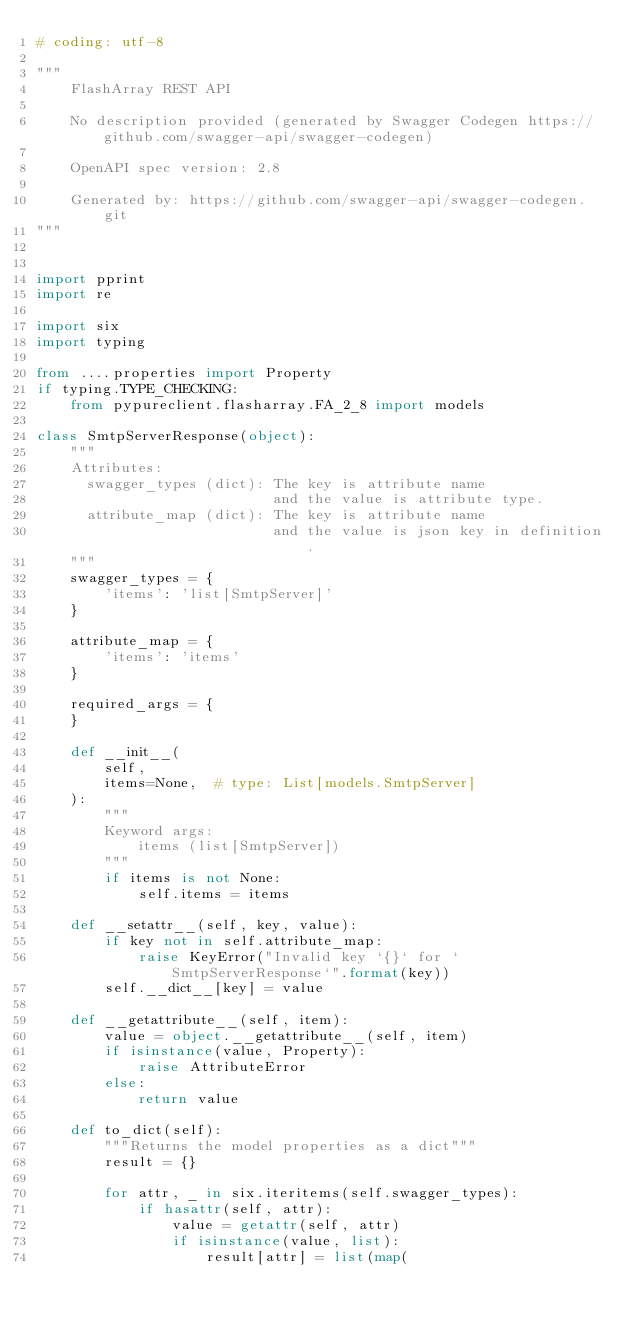Convert code to text. <code><loc_0><loc_0><loc_500><loc_500><_Python_># coding: utf-8

"""
    FlashArray REST API

    No description provided (generated by Swagger Codegen https://github.com/swagger-api/swagger-codegen)

    OpenAPI spec version: 2.8
    
    Generated by: https://github.com/swagger-api/swagger-codegen.git
"""


import pprint
import re

import six
import typing

from ....properties import Property
if typing.TYPE_CHECKING:
    from pypureclient.flasharray.FA_2_8 import models

class SmtpServerResponse(object):
    """
    Attributes:
      swagger_types (dict): The key is attribute name
                            and the value is attribute type.
      attribute_map (dict): The key is attribute name
                            and the value is json key in definition.
    """
    swagger_types = {
        'items': 'list[SmtpServer]'
    }

    attribute_map = {
        'items': 'items'
    }

    required_args = {
    }

    def __init__(
        self,
        items=None,  # type: List[models.SmtpServer]
    ):
        """
        Keyword args:
            items (list[SmtpServer])
        """
        if items is not None:
            self.items = items

    def __setattr__(self, key, value):
        if key not in self.attribute_map:
            raise KeyError("Invalid key `{}` for `SmtpServerResponse`".format(key))
        self.__dict__[key] = value

    def __getattribute__(self, item):
        value = object.__getattribute__(self, item)
        if isinstance(value, Property):
            raise AttributeError
        else:
            return value

    def to_dict(self):
        """Returns the model properties as a dict"""
        result = {}

        for attr, _ in six.iteritems(self.swagger_types):
            if hasattr(self, attr):
                value = getattr(self, attr)
                if isinstance(value, list):
                    result[attr] = list(map(</code> 